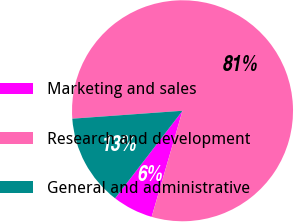<chart> <loc_0><loc_0><loc_500><loc_500><pie_chart><fcel>Marketing and sales<fcel>Research and development<fcel>General and administrative<nl><fcel>5.94%<fcel>80.64%<fcel>13.41%<nl></chart> 